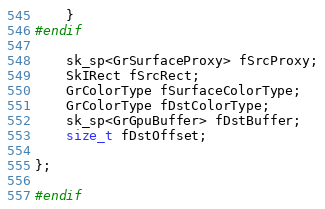Convert code to text. <code><loc_0><loc_0><loc_500><loc_500><_C_>    }
#endif

    sk_sp<GrSurfaceProxy> fSrcProxy;
    SkIRect fSrcRect;
    GrColorType fSurfaceColorType;
    GrColorType fDstColorType;
    sk_sp<GrGpuBuffer> fDstBuffer;
    size_t fDstOffset;

};

#endif

</code> 